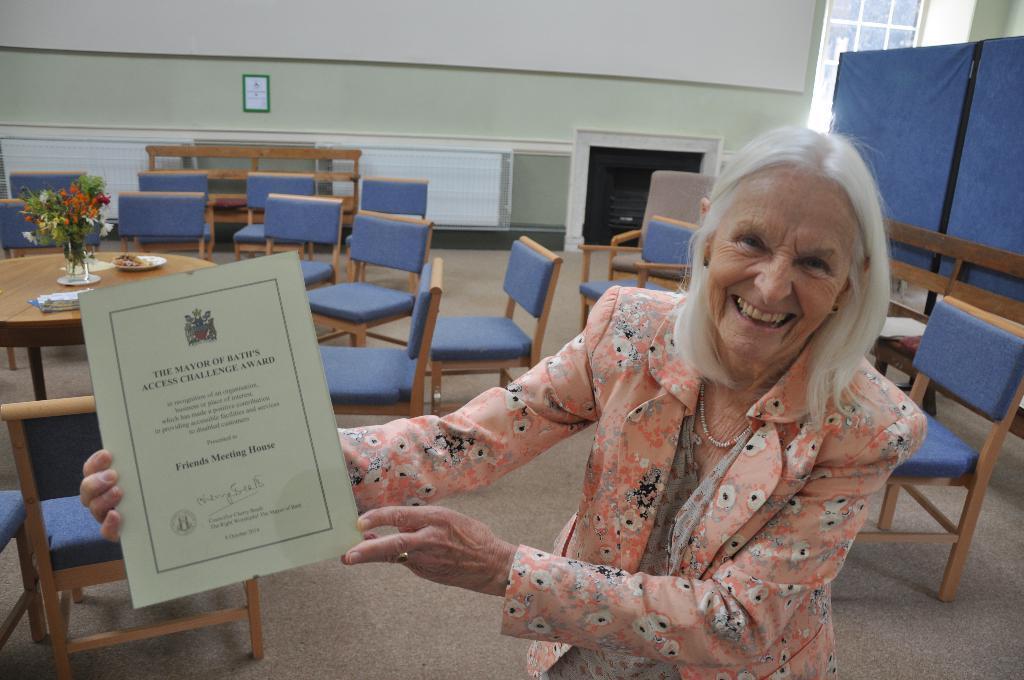In one or two sentences, can you explain what this image depicts? This picture shows a woman standing and holding a certificate in her hands and with a smile on her face and we see chairs and tables and a photo frame on the wall. 